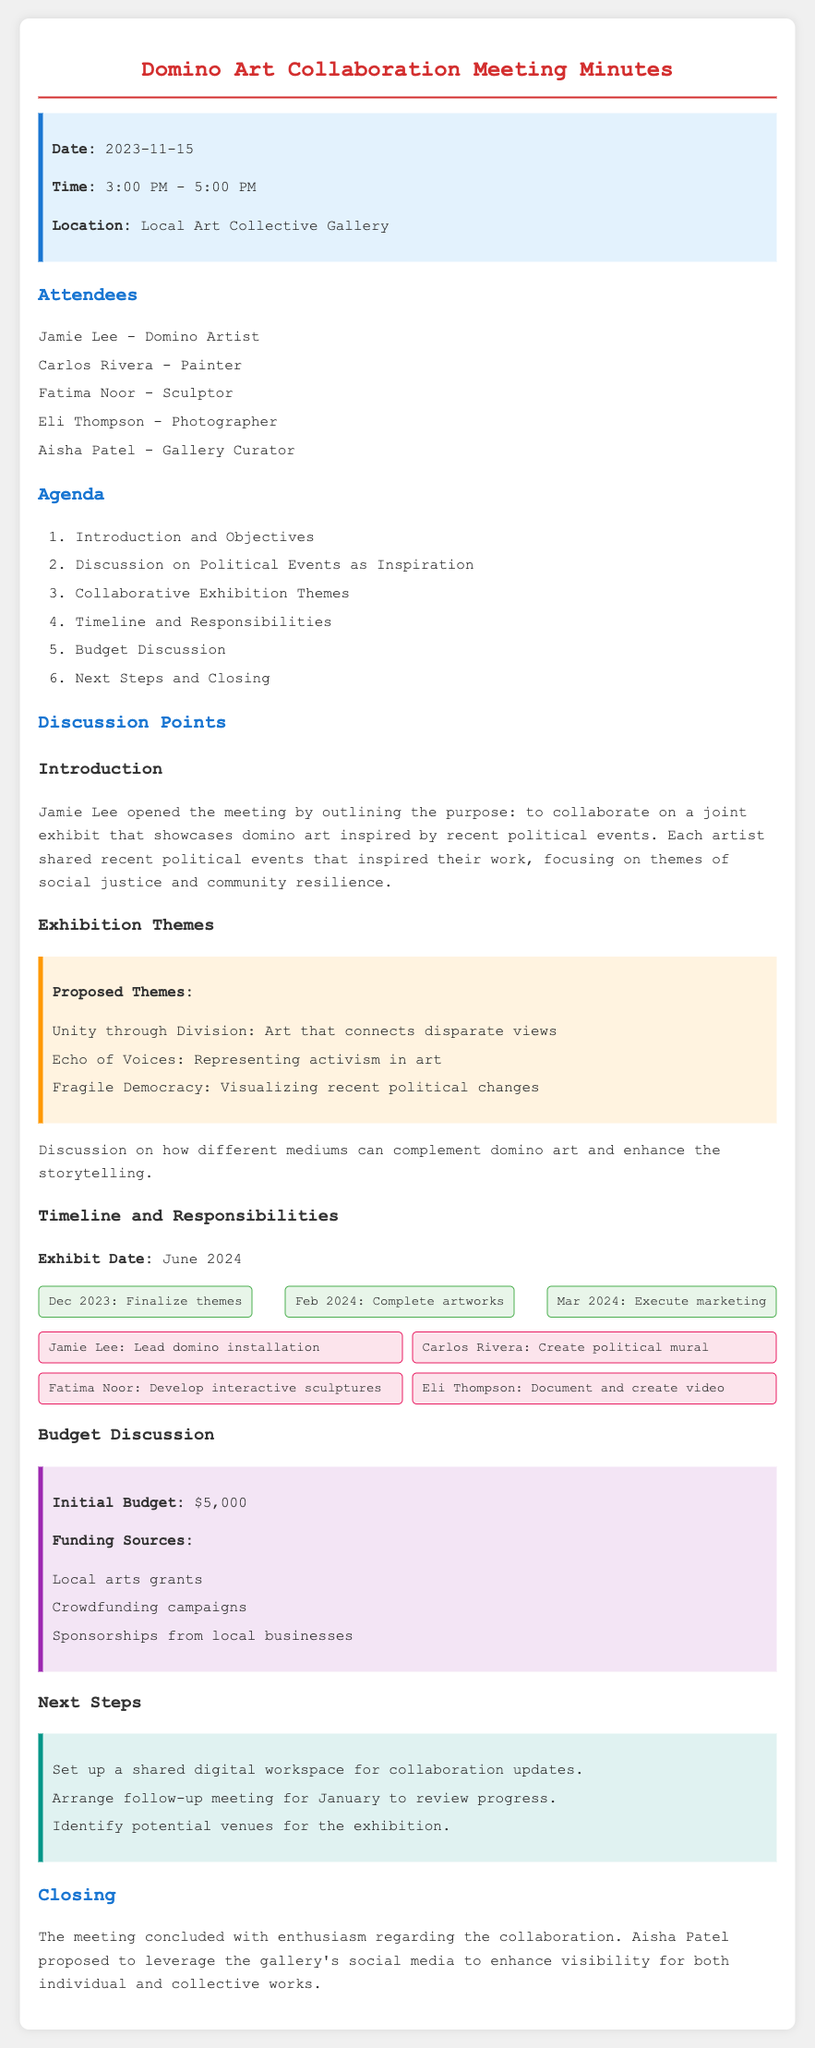What is the date of the meeting? The meeting date is explicitly mentioned at the beginning of the document under the info section.
Answer: 2023-11-15 Who is the lead domino installation artist? This information is found in the responsibilities section, where each artist's tasks are specified.
Answer: Jamie Lee What is the initial budget for the exhibit? The budget discussion section outlines the initial budget at the start.
Answer: $5,000 What is the exhibit date? The timeline section clearly states the planned date for the exhibition.
Answer: June 2024 What theme suggests art that connects disparate views? The proposed themes include ideas reflecting various aspects of political events and their expressions through art.
Answer: Unity through Division When is the follow-up meeting scheduled? The next steps section mentions arranging a follow-up meeting for progress review.
Answer: January What is one of the funding sources mentioned? The budget discussion includes a list of funding sources for the exhibit.
Answer: Local arts grants How many attendees were present at the meeting? The list of attendees at the beginning can be counted to determine the total number.
Answer: Five 